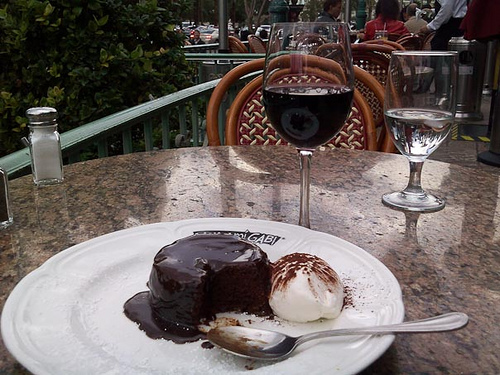Read and extract the text from this image. GABI 